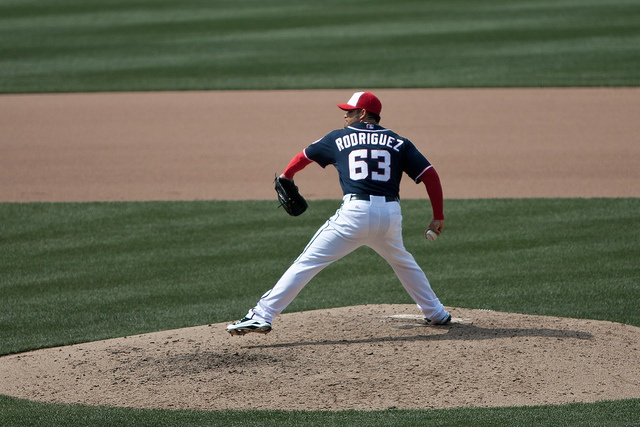Describe the objects in this image and their specific colors. I can see people in darkgreen, black, lavender, and gray tones, baseball glove in darkgreen, black, gray, and darkgray tones, and sports ball in darkgreen, gray, black, and maroon tones in this image. 